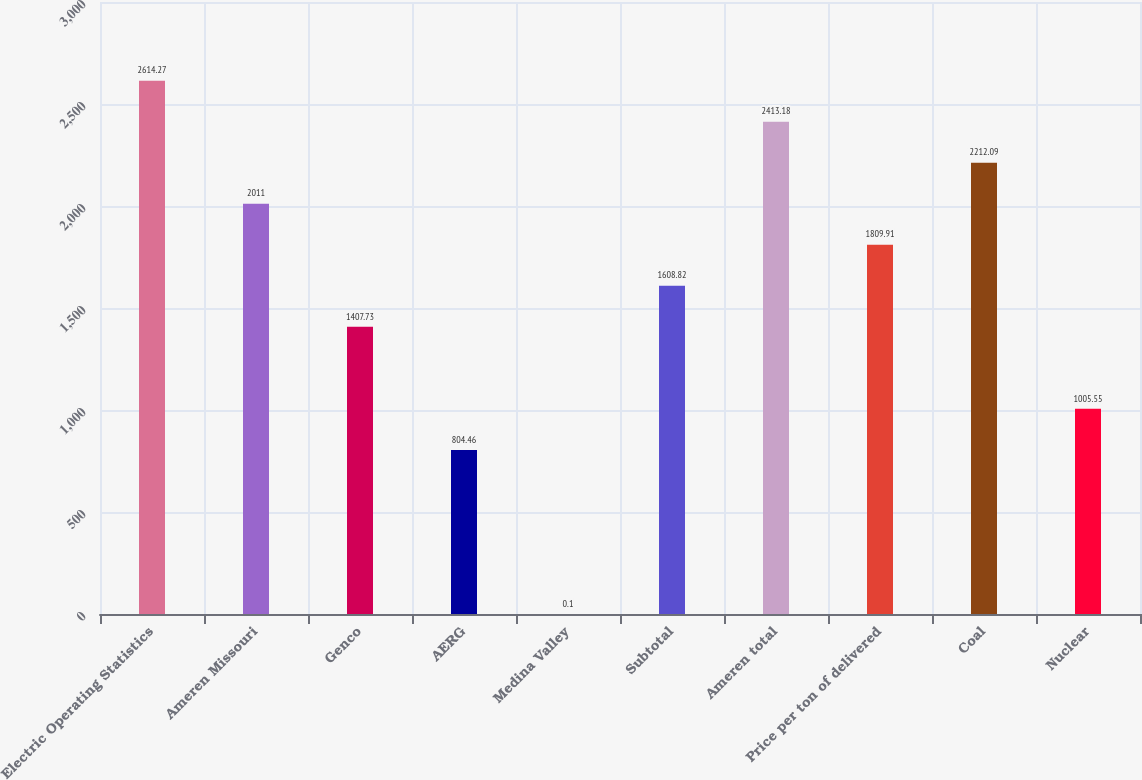<chart> <loc_0><loc_0><loc_500><loc_500><bar_chart><fcel>Electric Operating Statistics<fcel>Ameren Missouri<fcel>Genco<fcel>AERG<fcel>Medina Valley<fcel>Subtotal<fcel>Ameren total<fcel>Price per ton of delivered<fcel>Coal<fcel>Nuclear<nl><fcel>2614.27<fcel>2011<fcel>1407.73<fcel>804.46<fcel>0.1<fcel>1608.82<fcel>2413.18<fcel>1809.91<fcel>2212.09<fcel>1005.55<nl></chart> 